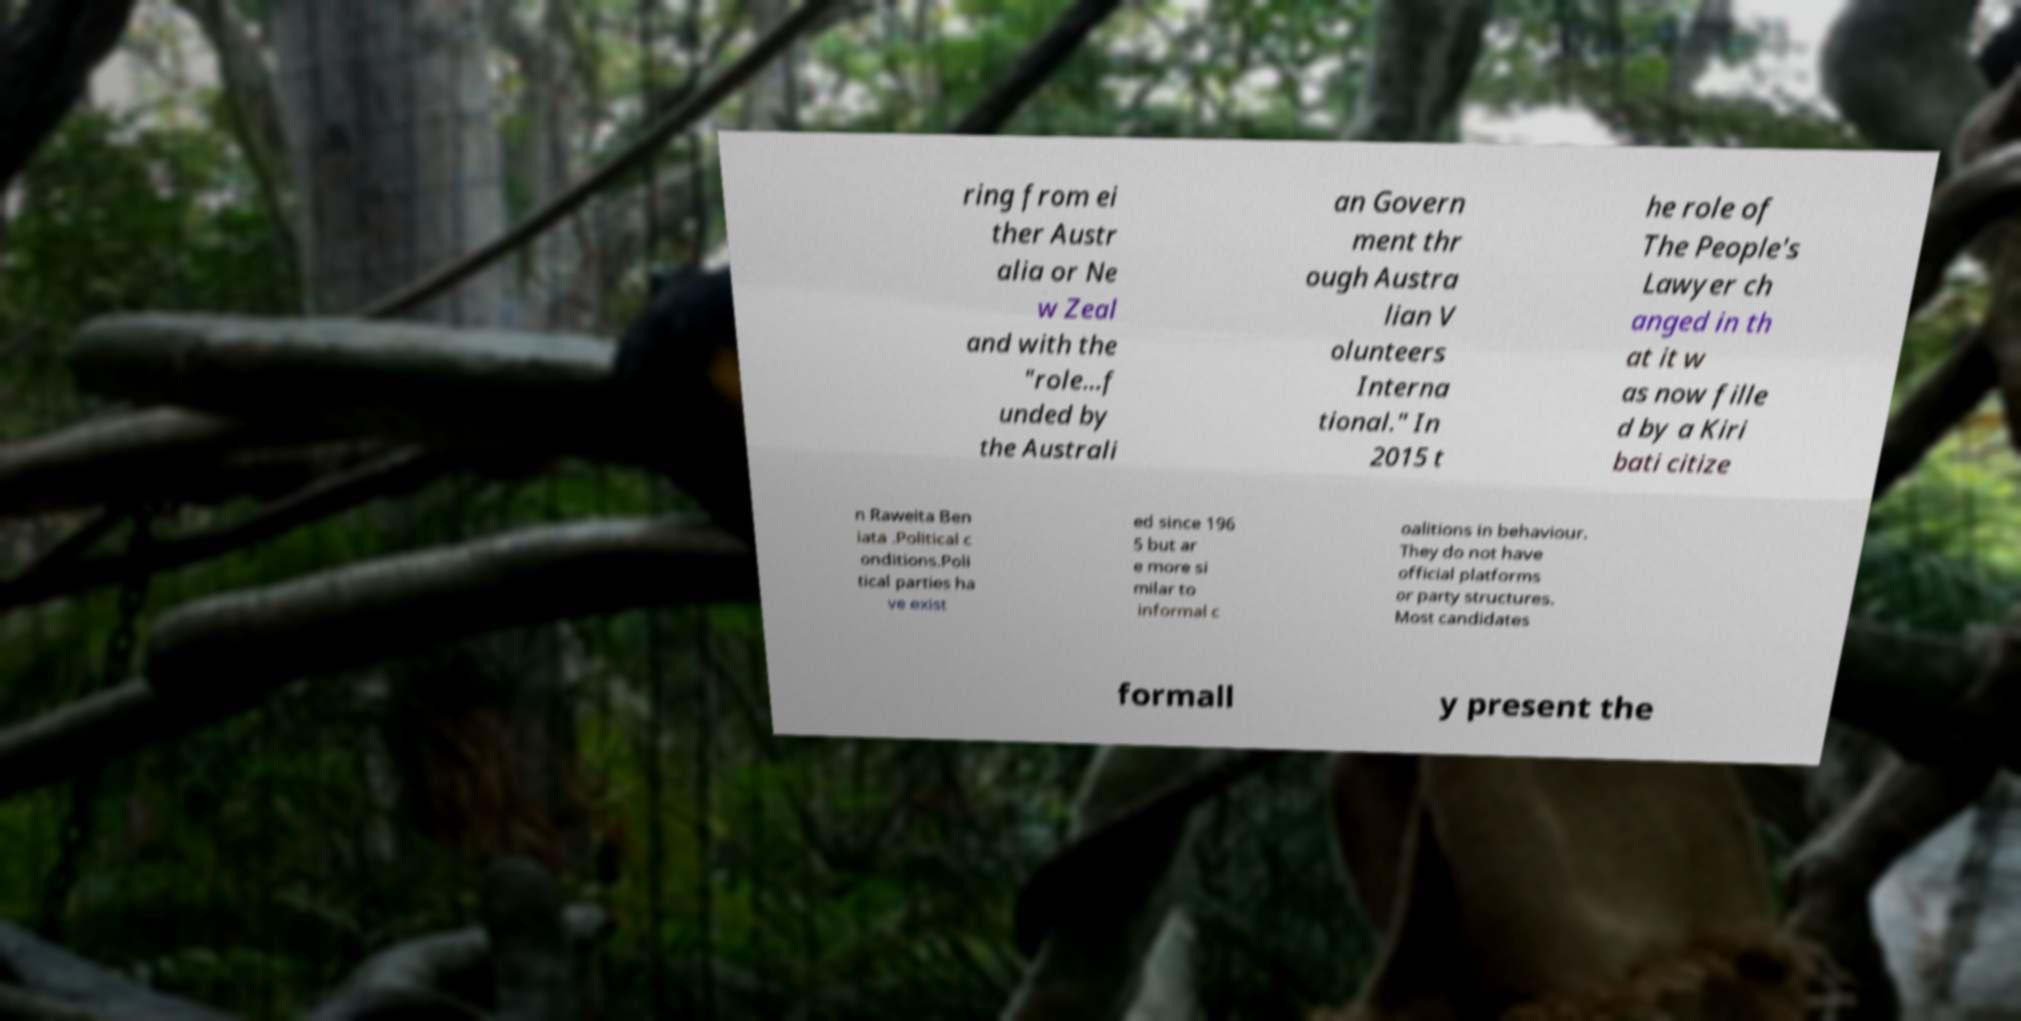Can you accurately transcribe the text from the provided image for me? ring from ei ther Austr alia or Ne w Zeal and with the "role...f unded by the Australi an Govern ment thr ough Austra lian V olunteers Interna tional." In 2015 t he role of The People's Lawyer ch anged in th at it w as now fille d by a Kiri bati citize n Raweita Ben iata .Political c onditions.Poli tical parties ha ve exist ed since 196 5 but ar e more si milar to informal c oalitions in behaviour. They do not have official platforms or party structures. Most candidates formall y present the 